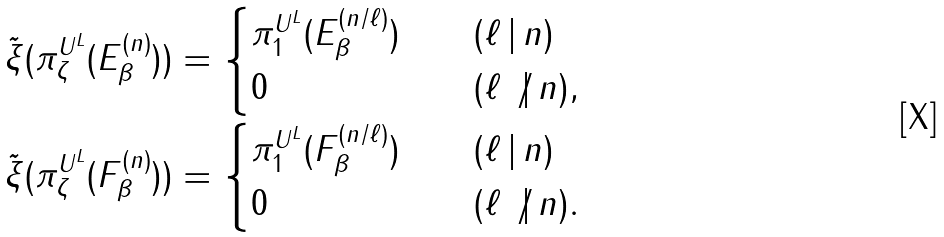Convert formula to latex. <formula><loc_0><loc_0><loc_500><loc_500>\tilde { \xi } ( { \pi } ^ { U ^ { L } } _ { \zeta } ( { E _ { \beta } ^ { ( n ) } } ) ) & = \begin{cases} { \pi } ^ { U ^ { L } } _ { 1 } ( { E _ { \beta } ^ { ( n / \ell ) } } ) \quad & ( \ell \, | \, n ) \\ 0 & ( \ell \not | \, n ) , \end{cases} \\ \tilde { \xi } ( { \pi } ^ { U ^ { L } } _ { \zeta } ( { F _ { \beta } ^ { ( n ) } } ) ) & = \begin{cases} { \pi } ^ { U ^ { L } } _ { 1 } ( { F _ { \beta } ^ { ( n / \ell ) } } ) \quad & ( \ell \, | \, n ) \\ 0 & ( \ell \not | \, n ) . \end{cases}</formula> 